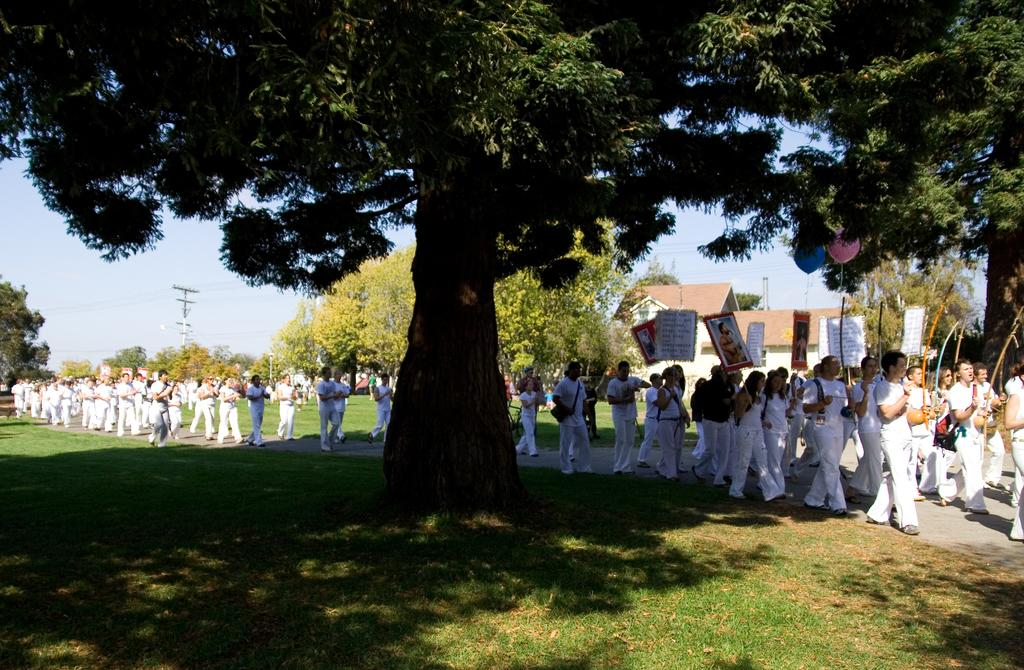What is happening in the image involving a group of people? The people in the image are walking. What are some of the people holding in the image? Some people are holding placards in the image. What can be seen in the background of the image? There are trees, poles, and a house in the background of the image. What time of day is it in the image, and how many mice can be seen running around? The time of day is not mentioned in the image, and there are no mice present. 